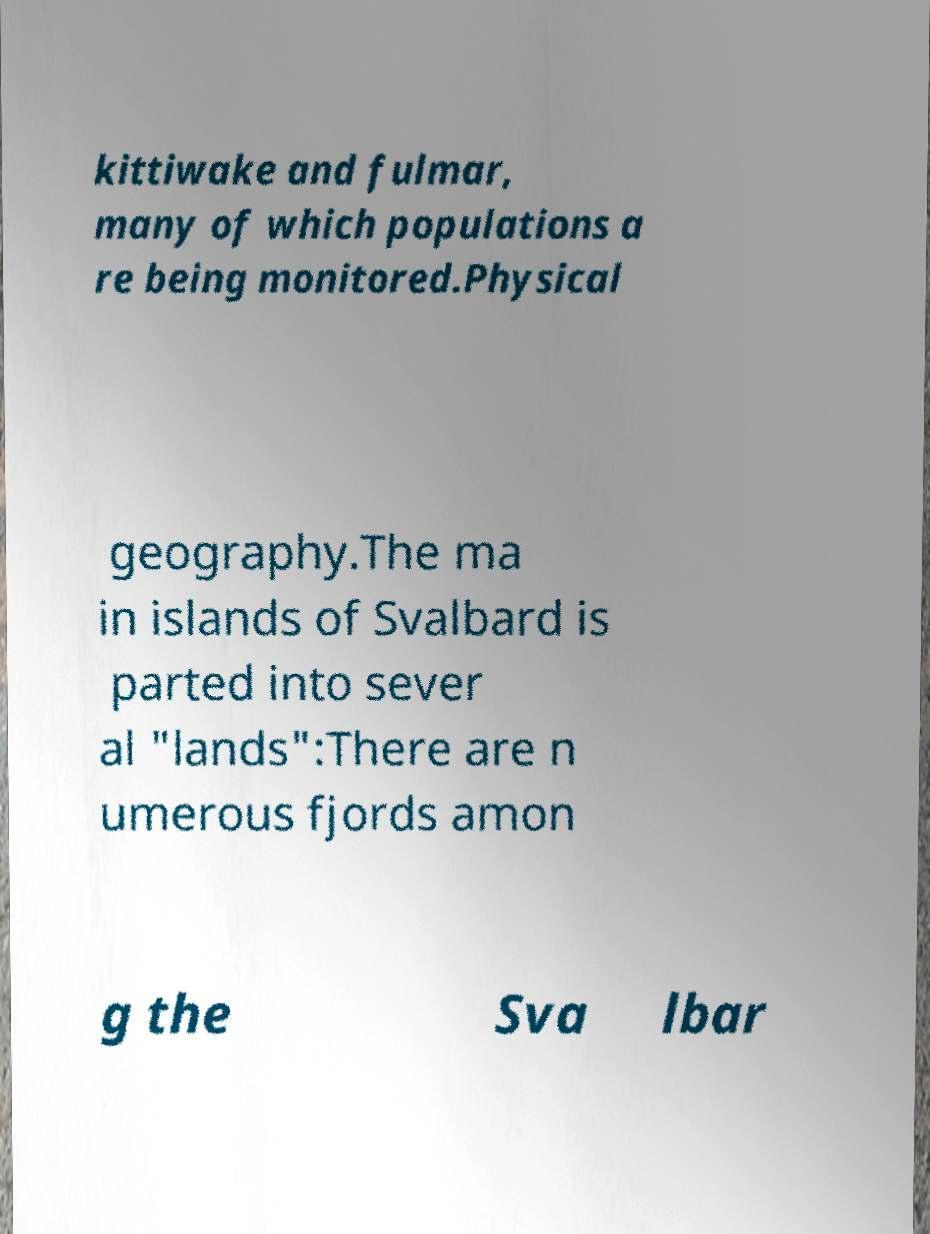Please read and relay the text visible in this image. What does it say? kittiwake and fulmar, many of which populations a re being monitored.Physical geography.The ma in islands of Svalbard is parted into sever al "lands":There are n umerous fjords amon g the Sva lbar 